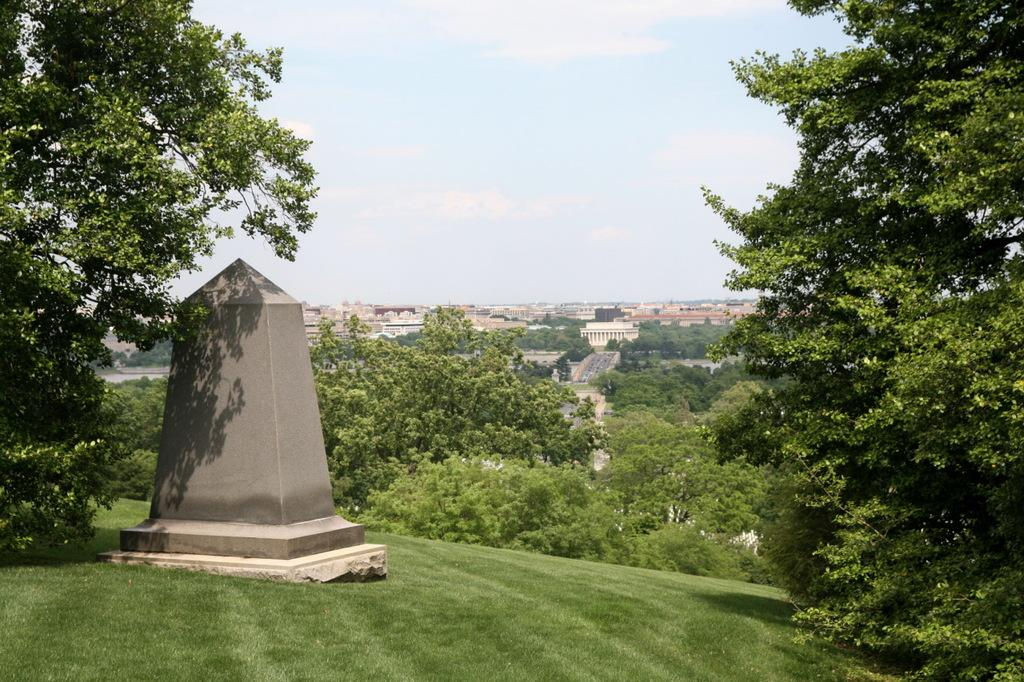What is the main subject of the image? There is a memorial in the image. What can be seen in the background of the image? There are trees and buildings in the background of the image. How are the trees described in the image? The trees are green in the image. How are the buildings described in the image? The buildings are white and brown in the image. What is the color of the sky in the image? The sky is white in color in the image. What type of hair can be seen on the pet in the image? There is no pet present in the image, and therefore no hair can be observed. What type of bulb is used to illuminate the memorial in the image? The image does not show any bulbs or lighting sources for the memorial, so it cannot be determined from the image. 